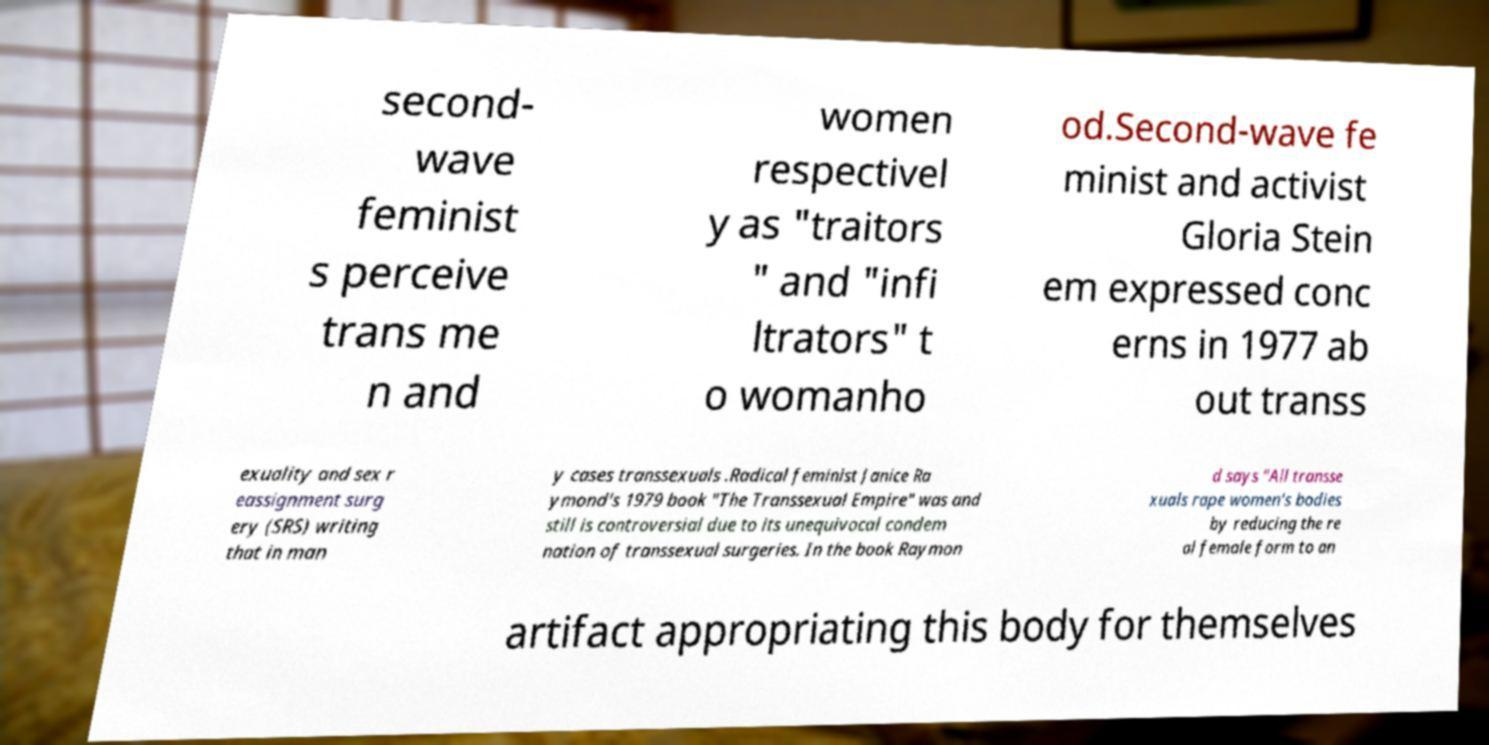I need the written content from this picture converted into text. Can you do that? second- wave feminist s perceive trans me n and women respectivel y as "traitors " and "infi ltrators" t o womanho od.Second-wave fe minist and activist Gloria Stein em expressed conc erns in 1977 ab out transs exuality and sex r eassignment surg ery (SRS) writing that in man y cases transsexuals .Radical feminist Janice Ra ymond's 1979 book "The Transsexual Empire" was and still is controversial due to its unequivocal condem nation of transsexual surgeries. In the book Raymon d says "All transse xuals rape women's bodies by reducing the re al female form to an artifact appropriating this body for themselves 